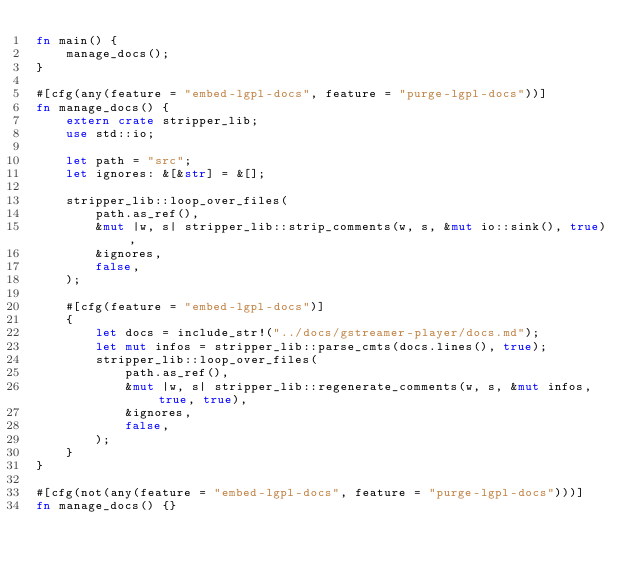Convert code to text. <code><loc_0><loc_0><loc_500><loc_500><_Rust_>fn main() {
    manage_docs();
}

#[cfg(any(feature = "embed-lgpl-docs", feature = "purge-lgpl-docs"))]
fn manage_docs() {
    extern crate stripper_lib;
    use std::io;

    let path = "src";
    let ignores: &[&str] = &[];

    stripper_lib::loop_over_files(
        path.as_ref(),
        &mut |w, s| stripper_lib::strip_comments(w, s, &mut io::sink(), true),
        &ignores,
        false,
    );

    #[cfg(feature = "embed-lgpl-docs")]
    {
        let docs = include_str!("../docs/gstreamer-player/docs.md");
        let mut infos = stripper_lib::parse_cmts(docs.lines(), true);
        stripper_lib::loop_over_files(
            path.as_ref(),
            &mut |w, s| stripper_lib::regenerate_comments(w, s, &mut infos, true, true),
            &ignores,
            false,
        );
    }
}

#[cfg(not(any(feature = "embed-lgpl-docs", feature = "purge-lgpl-docs")))]
fn manage_docs() {}
</code> 